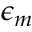<formula> <loc_0><loc_0><loc_500><loc_500>\epsilon _ { m }</formula> 